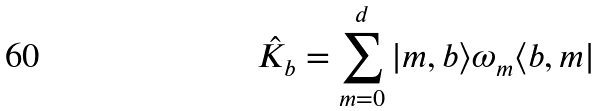Convert formula to latex. <formula><loc_0><loc_0><loc_500><loc_500>\hat { K } _ { b } = \sum _ { m = 0 } ^ { d } | m , b \rangle \omega _ { m } \langle b , m |</formula> 